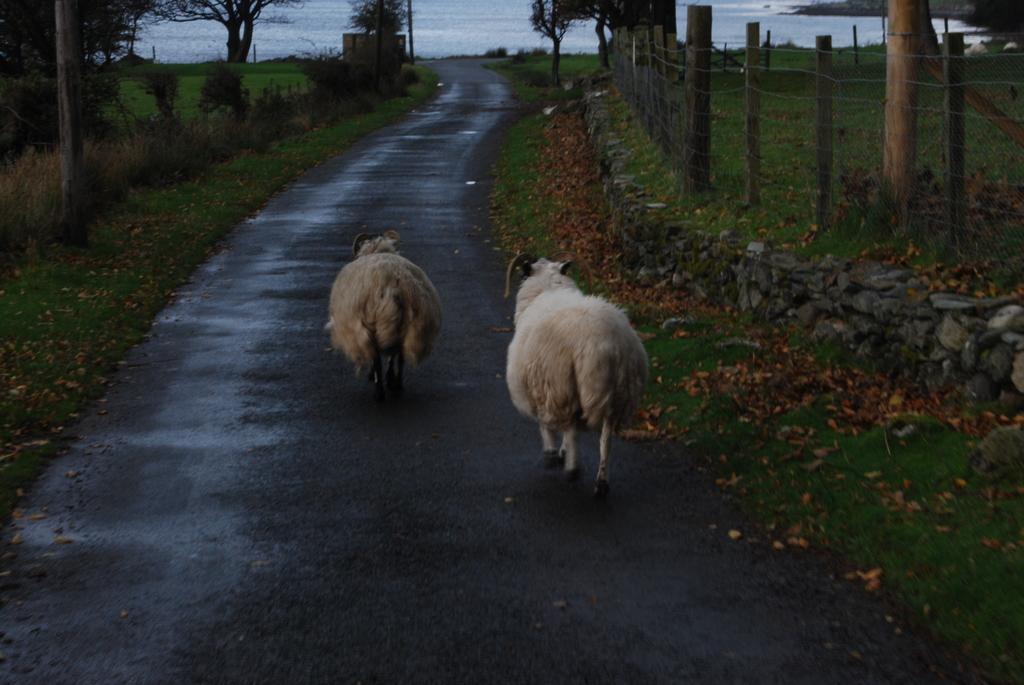Please provide a concise description of this image. This is an outside view. In the middle of the image there are two animals walking on the road towards the back side. On both sides of the road I can see the grass, few plants and poles. In the background there are some trees. At the top of the image it seems to be the water. 